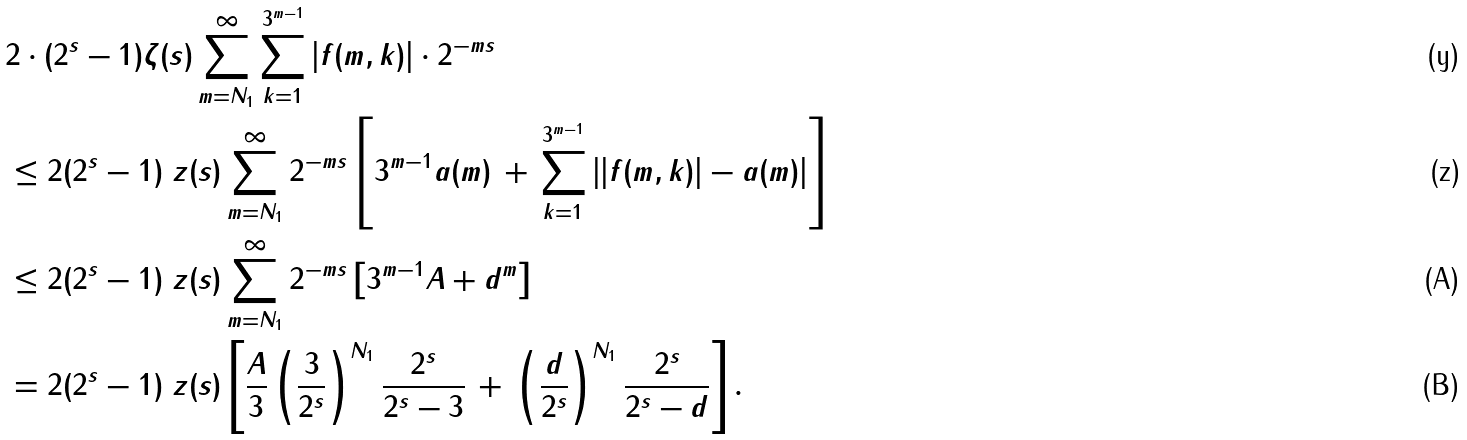<formula> <loc_0><loc_0><loc_500><loc_500>& 2 \cdot ( 2 ^ { s } - 1 ) \zeta ( s ) \sum _ { m = N _ { 1 } } ^ { \infty } \sum _ { k = 1 } ^ { 3 ^ { m - 1 } } | f ( m , k ) | \cdot 2 ^ { - m s } \\ & \leq 2 ( 2 ^ { s } - 1 ) \ z ( s ) \sum _ { m = N _ { 1 } } ^ { \infty } 2 ^ { - m s } \left [ 3 ^ { m - 1 } a ( m ) \, + \, \sum _ { k = 1 } ^ { 3 ^ { m - 1 } } \left | | f ( m , k ) | - a ( m ) \right | \right ] \\ & \leq 2 ( 2 ^ { s } - 1 ) \ z ( s ) \sum _ { m = N _ { 1 } } ^ { \infty } 2 ^ { - m s } \left [ 3 ^ { m - 1 } A + d ^ { m } \right ] \\ & = 2 ( 2 ^ { s } - 1 ) \ z ( s ) \left [ \frac { A } { 3 } \left ( \frac { 3 } { 2 ^ { s } } \right ) ^ { N _ { 1 } } \frac { 2 ^ { s } } { 2 ^ { s } - 3 } \, + \, \left ( \frac { d } { 2 ^ { s } } \right ) ^ { N _ { 1 } } \frac { 2 ^ { s } } { 2 ^ { s } - d } \right ] .</formula> 